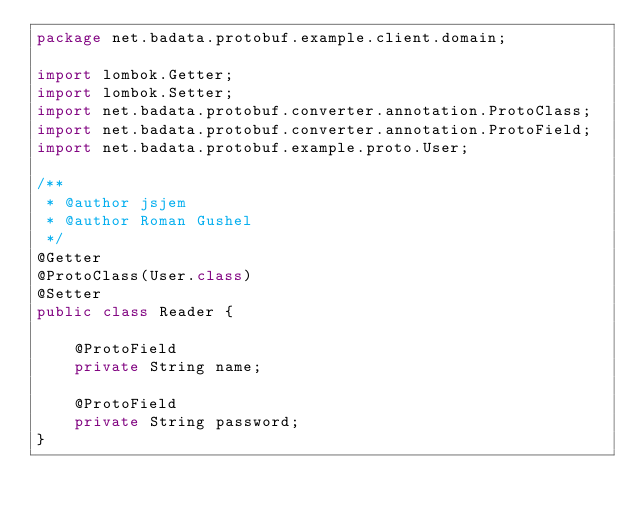<code> <loc_0><loc_0><loc_500><loc_500><_Java_>package net.badata.protobuf.example.client.domain;

import lombok.Getter;
import lombok.Setter;
import net.badata.protobuf.converter.annotation.ProtoClass;
import net.badata.protobuf.converter.annotation.ProtoField;
import net.badata.protobuf.example.proto.User;

/**
 * @author jsjem
 * @author Roman Gushel
 */
@Getter
@ProtoClass(User.class)
@Setter
public class Reader {

    @ProtoField
    private String name;

    @ProtoField
    private String password;
}
</code> 